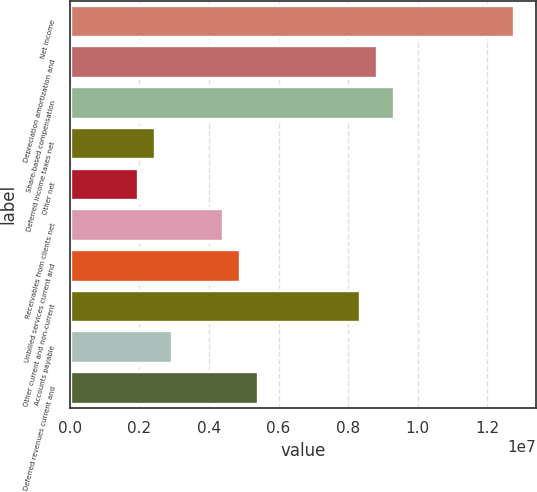Convert chart. <chart><loc_0><loc_0><loc_500><loc_500><bar_chart><fcel>Net income<fcel>Depreciation amortization and<fcel>Share-based compensation<fcel>Deferred income taxes net<fcel>Other net<fcel>Receivables from clients net<fcel>Unbilled services current and<fcel>Other current and non-current<fcel>Accounts payable<fcel>Deferred revenues current and<nl><fcel>1.27529e+07<fcel>8.82925e+06<fcel>9.3197e+06<fcel>2.45333e+06<fcel>1.96288e+06<fcel>4.41515e+06<fcel>4.90561e+06<fcel>8.33879e+06<fcel>2.94379e+06<fcel>5.39606e+06<nl></chart> 